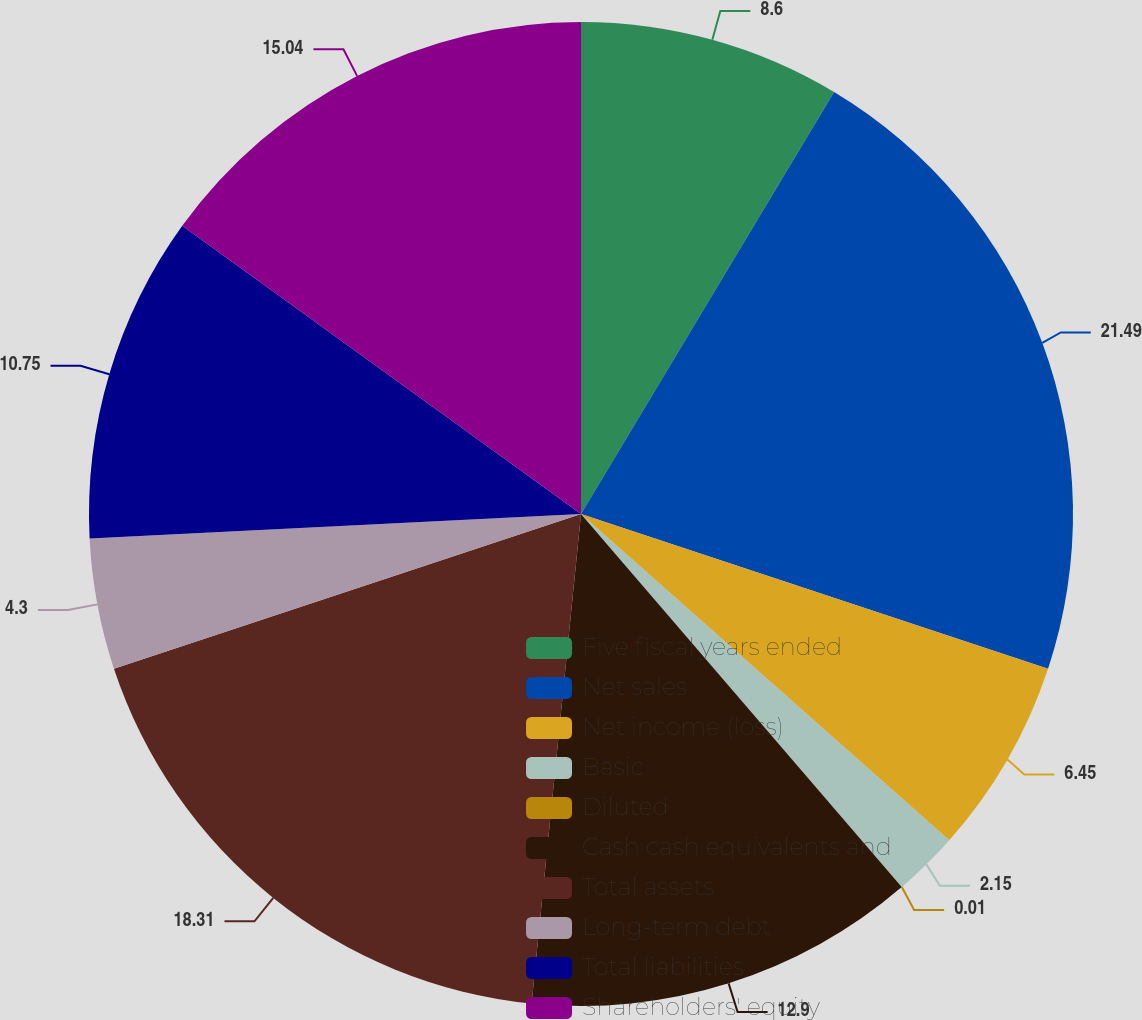<chart> <loc_0><loc_0><loc_500><loc_500><pie_chart><fcel>Five fiscal years ended<fcel>Net sales<fcel>Net income (loss)<fcel>Basic<fcel>Diluted<fcel>Cash cash equivalents and<fcel>Total assets<fcel>Long-term debt<fcel>Total liabilities<fcel>Shareholders' equity<nl><fcel>8.6%<fcel>21.49%<fcel>6.45%<fcel>2.15%<fcel>0.01%<fcel>12.9%<fcel>18.31%<fcel>4.3%<fcel>10.75%<fcel>15.04%<nl></chart> 